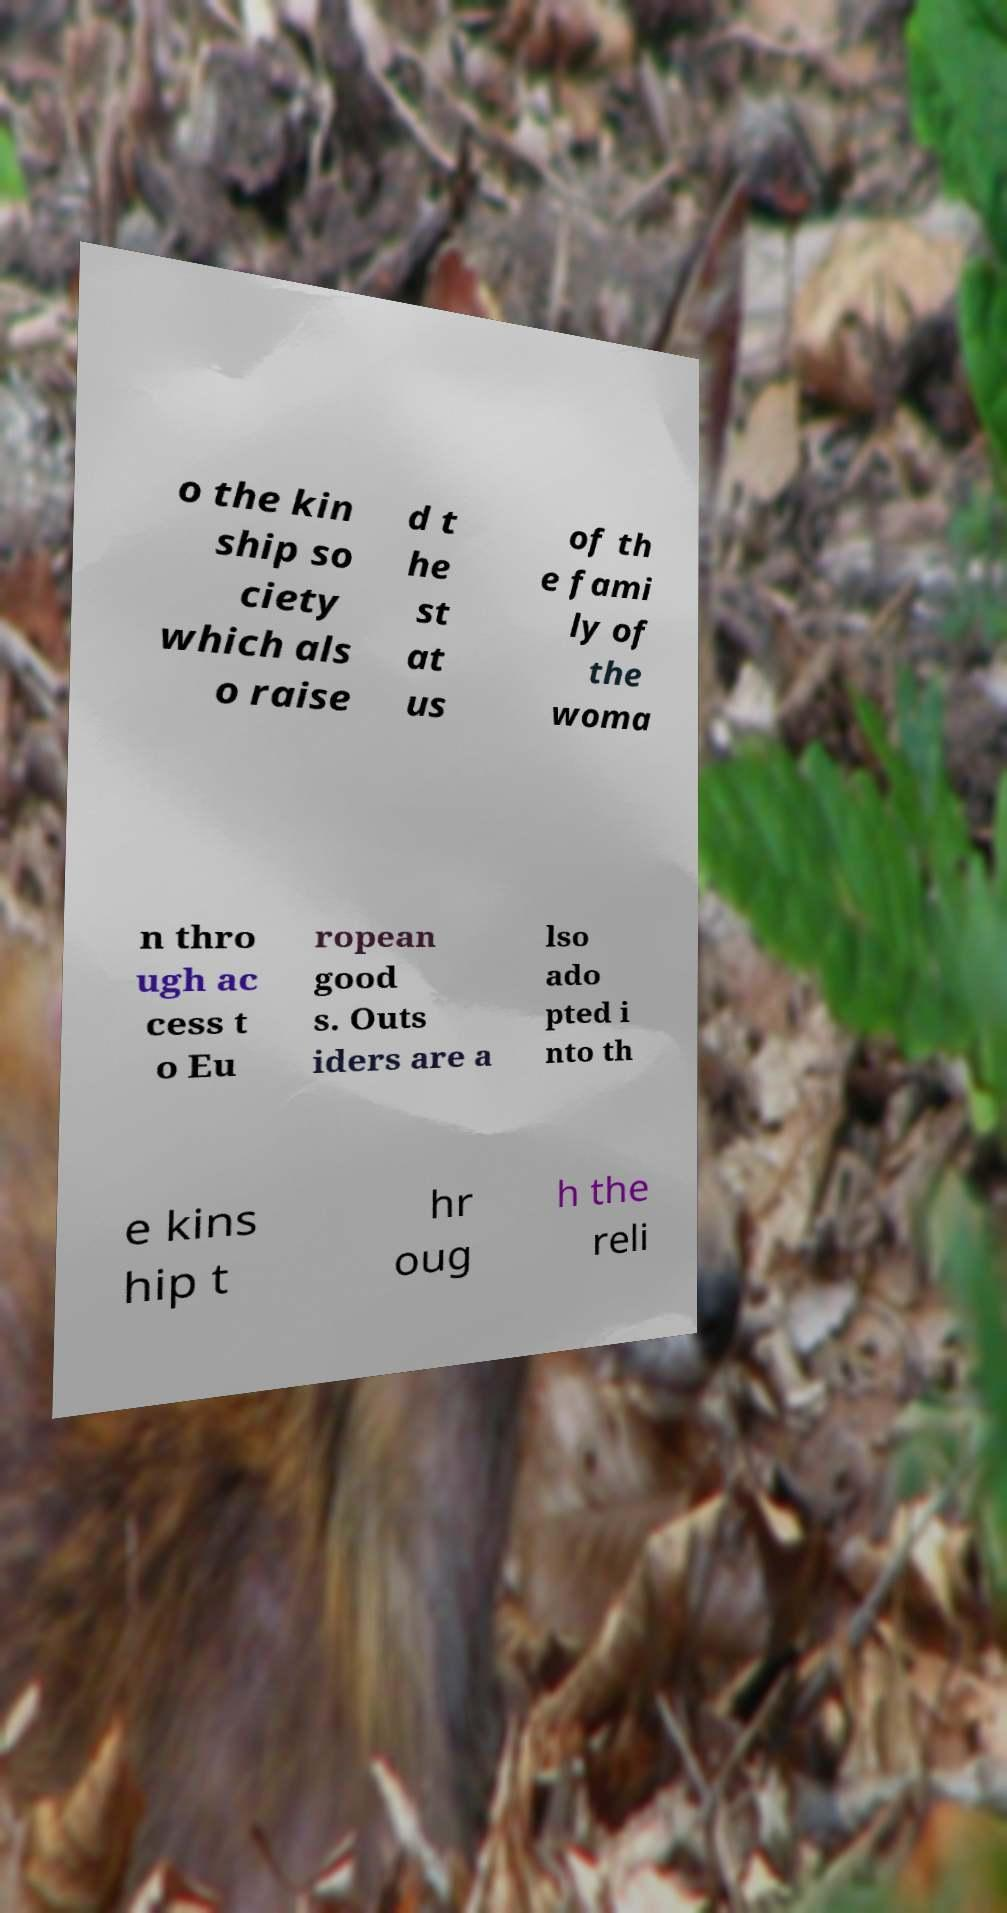Can you read and provide the text displayed in the image?This photo seems to have some interesting text. Can you extract and type it out for me? o the kin ship so ciety which als o raise d t he st at us of th e fami ly of the woma n thro ugh ac cess t o Eu ropean good s. Outs iders are a lso ado pted i nto th e kins hip t hr oug h the reli 